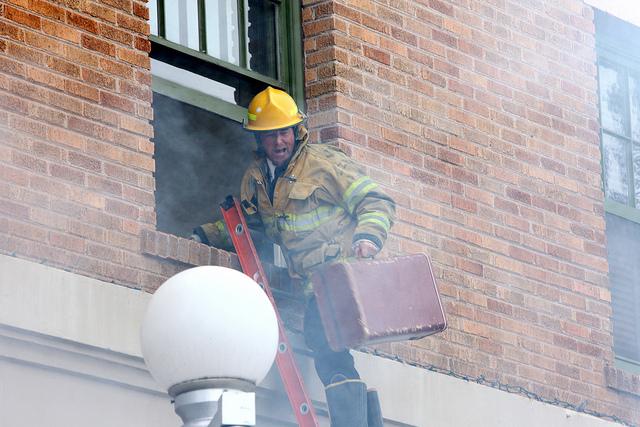What is this man's profession?
Be succinct. Firefighter. Is the building on fire?
Answer briefly. Yes. What color is the man's helmet?
Concise answer only. Yellow. 